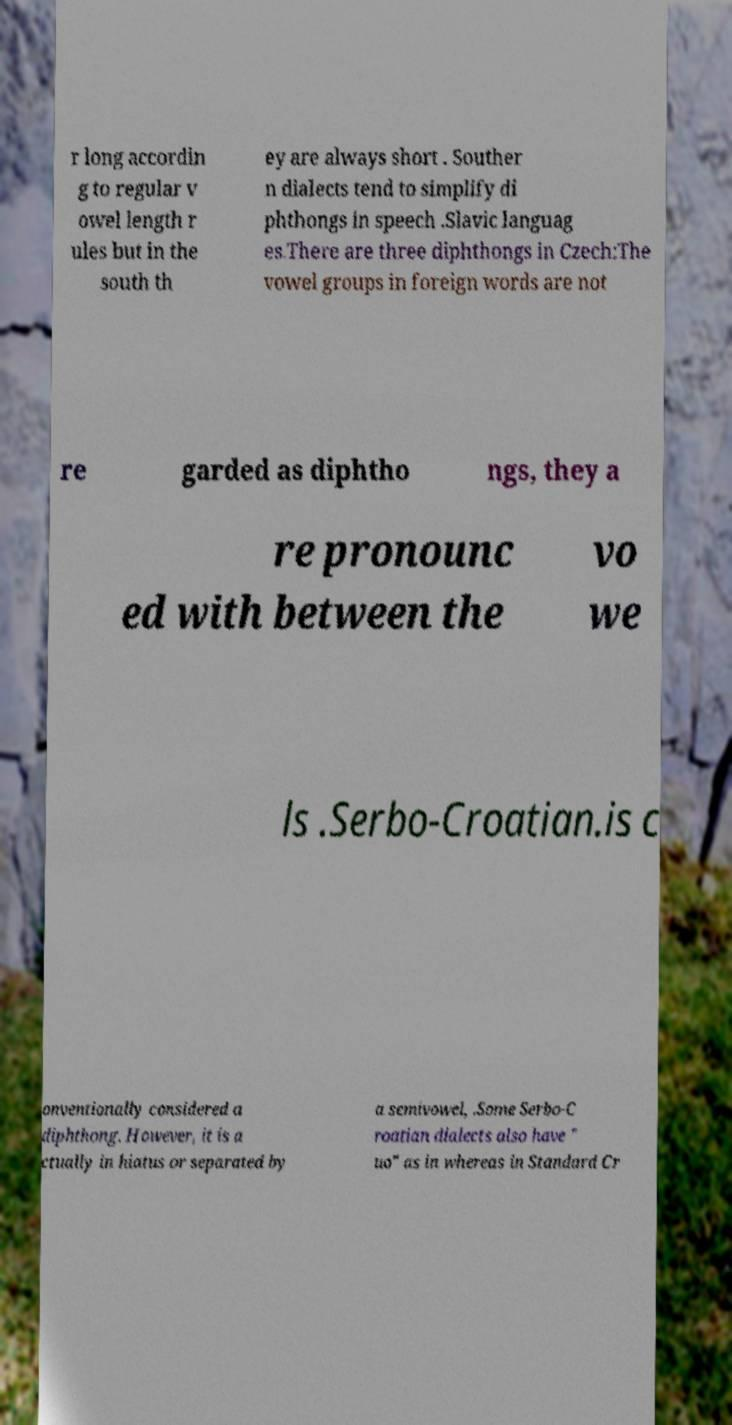Could you assist in decoding the text presented in this image and type it out clearly? r long accordin g to regular v owel length r ules but in the south th ey are always short . Souther n dialects tend to simplify di phthongs in speech .Slavic languag es.There are three diphthongs in Czech:The vowel groups in foreign words are not re garded as diphtho ngs, they a re pronounc ed with between the vo we ls .Serbo-Croatian.is c onventionally considered a diphthong. However, it is a ctually in hiatus or separated by a semivowel, .Some Serbo-C roatian dialects also have " uo" as in whereas in Standard Cr 